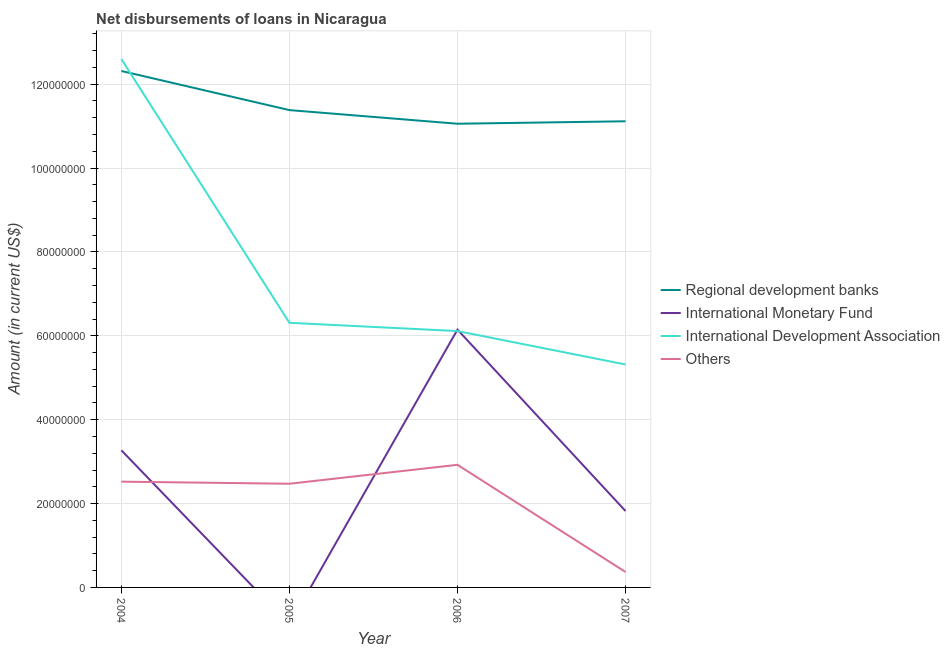Is the number of lines equal to the number of legend labels?
Provide a succinct answer. No. What is the amount of loan disimbursed by international monetary fund in 2006?
Give a very brief answer. 6.15e+07. Across all years, what is the maximum amount of loan disimbursed by regional development banks?
Keep it short and to the point. 1.23e+08. What is the total amount of loan disimbursed by international monetary fund in the graph?
Ensure brevity in your answer.  1.12e+08. What is the difference between the amount of loan disimbursed by other organisations in 2004 and that in 2006?
Offer a very short reply. -4.02e+06. What is the difference between the amount of loan disimbursed by international monetary fund in 2004 and the amount of loan disimbursed by regional development banks in 2006?
Your answer should be compact. -7.79e+07. What is the average amount of loan disimbursed by regional development banks per year?
Keep it short and to the point. 1.15e+08. In the year 2004, what is the difference between the amount of loan disimbursed by international development association and amount of loan disimbursed by international monetary fund?
Provide a short and direct response. 9.33e+07. In how many years, is the amount of loan disimbursed by regional development banks greater than 8000000 US$?
Keep it short and to the point. 4. What is the ratio of the amount of loan disimbursed by regional development banks in 2006 to that in 2007?
Give a very brief answer. 0.99. What is the difference between the highest and the second highest amount of loan disimbursed by other organisations?
Make the answer very short. 4.02e+06. What is the difference between the highest and the lowest amount of loan disimbursed by international monetary fund?
Provide a short and direct response. 6.15e+07. Is the sum of the amount of loan disimbursed by regional development banks in 2004 and 2005 greater than the maximum amount of loan disimbursed by international monetary fund across all years?
Offer a very short reply. Yes. Is it the case that in every year, the sum of the amount of loan disimbursed by regional development banks and amount of loan disimbursed by international monetary fund is greater than the amount of loan disimbursed by international development association?
Ensure brevity in your answer.  Yes. Does the amount of loan disimbursed by international monetary fund monotonically increase over the years?
Your response must be concise. No. Is the amount of loan disimbursed by international monetary fund strictly greater than the amount of loan disimbursed by international development association over the years?
Provide a short and direct response. No. How many lines are there?
Keep it short and to the point. 4. Does the graph contain grids?
Make the answer very short. Yes. Where does the legend appear in the graph?
Provide a short and direct response. Center right. How are the legend labels stacked?
Offer a very short reply. Vertical. What is the title of the graph?
Make the answer very short. Net disbursements of loans in Nicaragua. Does "Fish species" appear as one of the legend labels in the graph?
Keep it short and to the point. No. What is the label or title of the X-axis?
Provide a short and direct response. Year. What is the label or title of the Y-axis?
Your answer should be very brief. Amount (in current US$). What is the Amount (in current US$) of Regional development banks in 2004?
Your answer should be very brief. 1.23e+08. What is the Amount (in current US$) in International Monetary Fund in 2004?
Ensure brevity in your answer.  3.27e+07. What is the Amount (in current US$) of International Development Association in 2004?
Your response must be concise. 1.26e+08. What is the Amount (in current US$) of Others in 2004?
Provide a succinct answer. 2.52e+07. What is the Amount (in current US$) of Regional development banks in 2005?
Give a very brief answer. 1.14e+08. What is the Amount (in current US$) in International Monetary Fund in 2005?
Give a very brief answer. 0. What is the Amount (in current US$) in International Development Association in 2005?
Your response must be concise. 6.31e+07. What is the Amount (in current US$) in Others in 2005?
Your response must be concise. 2.47e+07. What is the Amount (in current US$) in Regional development banks in 2006?
Give a very brief answer. 1.11e+08. What is the Amount (in current US$) in International Monetary Fund in 2006?
Give a very brief answer. 6.15e+07. What is the Amount (in current US$) in International Development Association in 2006?
Keep it short and to the point. 6.11e+07. What is the Amount (in current US$) of Others in 2006?
Offer a terse response. 2.92e+07. What is the Amount (in current US$) of Regional development banks in 2007?
Your answer should be compact. 1.11e+08. What is the Amount (in current US$) of International Monetary Fund in 2007?
Offer a terse response. 1.82e+07. What is the Amount (in current US$) of International Development Association in 2007?
Your answer should be compact. 5.32e+07. What is the Amount (in current US$) of Others in 2007?
Offer a terse response. 3.68e+06. Across all years, what is the maximum Amount (in current US$) in Regional development banks?
Provide a succinct answer. 1.23e+08. Across all years, what is the maximum Amount (in current US$) of International Monetary Fund?
Provide a short and direct response. 6.15e+07. Across all years, what is the maximum Amount (in current US$) of International Development Association?
Your response must be concise. 1.26e+08. Across all years, what is the maximum Amount (in current US$) in Others?
Offer a very short reply. 2.92e+07. Across all years, what is the minimum Amount (in current US$) in Regional development banks?
Give a very brief answer. 1.11e+08. Across all years, what is the minimum Amount (in current US$) of International Monetary Fund?
Give a very brief answer. 0. Across all years, what is the minimum Amount (in current US$) of International Development Association?
Your response must be concise. 5.32e+07. Across all years, what is the minimum Amount (in current US$) of Others?
Give a very brief answer. 3.68e+06. What is the total Amount (in current US$) of Regional development banks in the graph?
Your response must be concise. 4.59e+08. What is the total Amount (in current US$) of International Monetary Fund in the graph?
Keep it short and to the point. 1.12e+08. What is the total Amount (in current US$) of International Development Association in the graph?
Provide a succinct answer. 3.03e+08. What is the total Amount (in current US$) of Others in the graph?
Keep it short and to the point. 8.29e+07. What is the difference between the Amount (in current US$) in Regional development banks in 2004 and that in 2005?
Give a very brief answer. 9.33e+06. What is the difference between the Amount (in current US$) of International Development Association in 2004 and that in 2005?
Make the answer very short. 6.29e+07. What is the difference between the Amount (in current US$) of Others in 2004 and that in 2005?
Offer a terse response. 4.97e+05. What is the difference between the Amount (in current US$) in Regional development banks in 2004 and that in 2006?
Your response must be concise. 1.26e+07. What is the difference between the Amount (in current US$) in International Monetary Fund in 2004 and that in 2006?
Make the answer very short. -2.88e+07. What is the difference between the Amount (in current US$) of International Development Association in 2004 and that in 2006?
Make the answer very short. 6.48e+07. What is the difference between the Amount (in current US$) in Others in 2004 and that in 2006?
Keep it short and to the point. -4.02e+06. What is the difference between the Amount (in current US$) of Regional development banks in 2004 and that in 2007?
Ensure brevity in your answer.  1.20e+07. What is the difference between the Amount (in current US$) in International Monetary Fund in 2004 and that in 2007?
Offer a very short reply. 1.45e+07. What is the difference between the Amount (in current US$) in International Development Association in 2004 and that in 2007?
Offer a terse response. 7.28e+07. What is the difference between the Amount (in current US$) of Others in 2004 and that in 2007?
Your response must be concise. 2.15e+07. What is the difference between the Amount (in current US$) of Regional development banks in 2005 and that in 2006?
Your answer should be very brief. 3.25e+06. What is the difference between the Amount (in current US$) of International Development Association in 2005 and that in 2006?
Make the answer very short. 1.97e+06. What is the difference between the Amount (in current US$) of Others in 2005 and that in 2006?
Offer a very short reply. -4.52e+06. What is the difference between the Amount (in current US$) in Regional development banks in 2005 and that in 2007?
Your answer should be compact. 2.66e+06. What is the difference between the Amount (in current US$) of International Development Association in 2005 and that in 2007?
Offer a terse response. 9.94e+06. What is the difference between the Amount (in current US$) in Others in 2005 and that in 2007?
Offer a terse response. 2.10e+07. What is the difference between the Amount (in current US$) in Regional development banks in 2006 and that in 2007?
Offer a terse response. -5.87e+05. What is the difference between the Amount (in current US$) in International Monetary Fund in 2006 and that in 2007?
Your answer should be very brief. 4.33e+07. What is the difference between the Amount (in current US$) in International Development Association in 2006 and that in 2007?
Your answer should be compact. 7.97e+06. What is the difference between the Amount (in current US$) in Others in 2006 and that in 2007?
Offer a terse response. 2.56e+07. What is the difference between the Amount (in current US$) of Regional development banks in 2004 and the Amount (in current US$) of International Development Association in 2005?
Keep it short and to the point. 6.00e+07. What is the difference between the Amount (in current US$) in Regional development banks in 2004 and the Amount (in current US$) in Others in 2005?
Ensure brevity in your answer.  9.84e+07. What is the difference between the Amount (in current US$) in International Monetary Fund in 2004 and the Amount (in current US$) in International Development Association in 2005?
Offer a terse response. -3.04e+07. What is the difference between the Amount (in current US$) of International Monetary Fund in 2004 and the Amount (in current US$) of Others in 2005?
Offer a terse response. 7.97e+06. What is the difference between the Amount (in current US$) of International Development Association in 2004 and the Amount (in current US$) of Others in 2005?
Ensure brevity in your answer.  1.01e+08. What is the difference between the Amount (in current US$) of Regional development banks in 2004 and the Amount (in current US$) of International Monetary Fund in 2006?
Your response must be concise. 6.17e+07. What is the difference between the Amount (in current US$) in Regional development banks in 2004 and the Amount (in current US$) in International Development Association in 2006?
Give a very brief answer. 6.20e+07. What is the difference between the Amount (in current US$) of Regional development banks in 2004 and the Amount (in current US$) of Others in 2006?
Offer a terse response. 9.39e+07. What is the difference between the Amount (in current US$) of International Monetary Fund in 2004 and the Amount (in current US$) of International Development Association in 2006?
Your answer should be compact. -2.84e+07. What is the difference between the Amount (in current US$) of International Monetary Fund in 2004 and the Amount (in current US$) of Others in 2006?
Offer a very short reply. 3.45e+06. What is the difference between the Amount (in current US$) in International Development Association in 2004 and the Amount (in current US$) in Others in 2006?
Provide a succinct answer. 9.67e+07. What is the difference between the Amount (in current US$) of Regional development banks in 2004 and the Amount (in current US$) of International Monetary Fund in 2007?
Your answer should be compact. 1.05e+08. What is the difference between the Amount (in current US$) in Regional development banks in 2004 and the Amount (in current US$) in International Development Association in 2007?
Make the answer very short. 7.00e+07. What is the difference between the Amount (in current US$) of Regional development banks in 2004 and the Amount (in current US$) of Others in 2007?
Offer a terse response. 1.19e+08. What is the difference between the Amount (in current US$) in International Monetary Fund in 2004 and the Amount (in current US$) in International Development Association in 2007?
Offer a very short reply. -2.05e+07. What is the difference between the Amount (in current US$) in International Monetary Fund in 2004 and the Amount (in current US$) in Others in 2007?
Offer a very short reply. 2.90e+07. What is the difference between the Amount (in current US$) of International Development Association in 2004 and the Amount (in current US$) of Others in 2007?
Your answer should be very brief. 1.22e+08. What is the difference between the Amount (in current US$) of Regional development banks in 2005 and the Amount (in current US$) of International Monetary Fund in 2006?
Offer a very short reply. 5.23e+07. What is the difference between the Amount (in current US$) of Regional development banks in 2005 and the Amount (in current US$) of International Development Association in 2006?
Keep it short and to the point. 5.27e+07. What is the difference between the Amount (in current US$) of Regional development banks in 2005 and the Amount (in current US$) of Others in 2006?
Keep it short and to the point. 8.46e+07. What is the difference between the Amount (in current US$) in International Development Association in 2005 and the Amount (in current US$) in Others in 2006?
Make the answer very short. 3.39e+07. What is the difference between the Amount (in current US$) of Regional development banks in 2005 and the Amount (in current US$) of International Monetary Fund in 2007?
Your answer should be very brief. 9.56e+07. What is the difference between the Amount (in current US$) of Regional development banks in 2005 and the Amount (in current US$) of International Development Association in 2007?
Offer a terse response. 6.07e+07. What is the difference between the Amount (in current US$) of Regional development banks in 2005 and the Amount (in current US$) of Others in 2007?
Provide a short and direct response. 1.10e+08. What is the difference between the Amount (in current US$) of International Development Association in 2005 and the Amount (in current US$) of Others in 2007?
Make the answer very short. 5.94e+07. What is the difference between the Amount (in current US$) of Regional development banks in 2006 and the Amount (in current US$) of International Monetary Fund in 2007?
Your response must be concise. 9.23e+07. What is the difference between the Amount (in current US$) in Regional development banks in 2006 and the Amount (in current US$) in International Development Association in 2007?
Your answer should be very brief. 5.74e+07. What is the difference between the Amount (in current US$) of Regional development banks in 2006 and the Amount (in current US$) of Others in 2007?
Provide a short and direct response. 1.07e+08. What is the difference between the Amount (in current US$) in International Monetary Fund in 2006 and the Amount (in current US$) in International Development Association in 2007?
Ensure brevity in your answer.  8.32e+06. What is the difference between the Amount (in current US$) of International Monetary Fund in 2006 and the Amount (in current US$) of Others in 2007?
Your answer should be very brief. 5.78e+07. What is the difference between the Amount (in current US$) in International Development Association in 2006 and the Amount (in current US$) in Others in 2007?
Your answer should be compact. 5.74e+07. What is the average Amount (in current US$) in Regional development banks per year?
Provide a succinct answer. 1.15e+08. What is the average Amount (in current US$) in International Monetary Fund per year?
Offer a terse response. 2.81e+07. What is the average Amount (in current US$) of International Development Association per year?
Provide a succinct answer. 7.58e+07. What is the average Amount (in current US$) in Others per year?
Offer a terse response. 2.07e+07. In the year 2004, what is the difference between the Amount (in current US$) in Regional development banks and Amount (in current US$) in International Monetary Fund?
Provide a succinct answer. 9.05e+07. In the year 2004, what is the difference between the Amount (in current US$) in Regional development banks and Amount (in current US$) in International Development Association?
Your answer should be compact. -2.84e+06. In the year 2004, what is the difference between the Amount (in current US$) in Regional development banks and Amount (in current US$) in Others?
Keep it short and to the point. 9.79e+07. In the year 2004, what is the difference between the Amount (in current US$) in International Monetary Fund and Amount (in current US$) in International Development Association?
Ensure brevity in your answer.  -9.33e+07. In the year 2004, what is the difference between the Amount (in current US$) in International Monetary Fund and Amount (in current US$) in Others?
Provide a short and direct response. 7.47e+06. In the year 2004, what is the difference between the Amount (in current US$) in International Development Association and Amount (in current US$) in Others?
Your answer should be compact. 1.01e+08. In the year 2005, what is the difference between the Amount (in current US$) in Regional development banks and Amount (in current US$) in International Development Association?
Your answer should be very brief. 5.07e+07. In the year 2005, what is the difference between the Amount (in current US$) of Regional development banks and Amount (in current US$) of Others?
Your response must be concise. 8.91e+07. In the year 2005, what is the difference between the Amount (in current US$) of International Development Association and Amount (in current US$) of Others?
Make the answer very short. 3.84e+07. In the year 2006, what is the difference between the Amount (in current US$) of Regional development banks and Amount (in current US$) of International Monetary Fund?
Offer a very short reply. 4.91e+07. In the year 2006, what is the difference between the Amount (in current US$) of Regional development banks and Amount (in current US$) of International Development Association?
Ensure brevity in your answer.  4.94e+07. In the year 2006, what is the difference between the Amount (in current US$) in Regional development banks and Amount (in current US$) in Others?
Offer a terse response. 8.13e+07. In the year 2006, what is the difference between the Amount (in current US$) in International Monetary Fund and Amount (in current US$) in International Development Association?
Provide a succinct answer. 3.43e+05. In the year 2006, what is the difference between the Amount (in current US$) in International Monetary Fund and Amount (in current US$) in Others?
Offer a terse response. 3.22e+07. In the year 2006, what is the difference between the Amount (in current US$) of International Development Association and Amount (in current US$) of Others?
Provide a succinct answer. 3.19e+07. In the year 2007, what is the difference between the Amount (in current US$) in Regional development banks and Amount (in current US$) in International Monetary Fund?
Give a very brief answer. 9.29e+07. In the year 2007, what is the difference between the Amount (in current US$) of Regional development banks and Amount (in current US$) of International Development Association?
Provide a short and direct response. 5.80e+07. In the year 2007, what is the difference between the Amount (in current US$) in Regional development banks and Amount (in current US$) in Others?
Make the answer very short. 1.07e+08. In the year 2007, what is the difference between the Amount (in current US$) of International Monetary Fund and Amount (in current US$) of International Development Association?
Your answer should be very brief. -3.49e+07. In the year 2007, what is the difference between the Amount (in current US$) of International Monetary Fund and Amount (in current US$) of Others?
Give a very brief answer. 1.45e+07. In the year 2007, what is the difference between the Amount (in current US$) in International Development Association and Amount (in current US$) in Others?
Offer a terse response. 4.95e+07. What is the ratio of the Amount (in current US$) in Regional development banks in 2004 to that in 2005?
Your answer should be compact. 1.08. What is the ratio of the Amount (in current US$) of International Development Association in 2004 to that in 2005?
Provide a succinct answer. 2. What is the ratio of the Amount (in current US$) in Others in 2004 to that in 2005?
Your answer should be very brief. 1.02. What is the ratio of the Amount (in current US$) in Regional development banks in 2004 to that in 2006?
Provide a short and direct response. 1.11. What is the ratio of the Amount (in current US$) of International Monetary Fund in 2004 to that in 2006?
Ensure brevity in your answer.  0.53. What is the ratio of the Amount (in current US$) of International Development Association in 2004 to that in 2006?
Your answer should be compact. 2.06. What is the ratio of the Amount (in current US$) of Others in 2004 to that in 2006?
Your answer should be very brief. 0.86. What is the ratio of the Amount (in current US$) of Regional development banks in 2004 to that in 2007?
Offer a very short reply. 1.11. What is the ratio of the Amount (in current US$) of International Monetary Fund in 2004 to that in 2007?
Provide a succinct answer. 1.79. What is the ratio of the Amount (in current US$) in International Development Association in 2004 to that in 2007?
Provide a succinct answer. 2.37. What is the ratio of the Amount (in current US$) of Others in 2004 to that in 2007?
Ensure brevity in your answer.  6.85. What is the ratio of the Amount (in current US$) in Regional development banks in 2005 to that in 2006?
Offer a very short reply. 1.03. What is the ratio of the Amount (in current US$) in International Development Association in 2005 to that in 2006?
Keep it short and to the point. 1.03. What is the ratio of the Amount (in current US$) in Others in 2005 to that in 2006?
Keep it short and to the point. 0.85. What is the ratio of the Amount (in current US$) in International Development Association in 2005 to that in 2007?
Make the answer very short. 1.19. What is the ratio of the Amount (in current US$) of Others in 2005 to that in 2007?
Keep it short and to the point. 6.71. What is the ratio of the Amount (in current US$) of Regional development banks in 2006 to that in 2007?
Your response must be concise. 0.99. What is the ratio of the Amount (in current US$) in International Monetary Fund in 2006 to that in 2007?
Make the answer very short. 3.37. What is the ratio of the Amount (in current US$) in International Development Association in 2006 to that in 2007?
Provide a succinct answer. 1.15. What is the ratio of the Amount (in current US$) of Others in 2006 to that in 2007?
Your response must be concise. 7.94. What is the difference between the highest and the second highest Amount (in current US$) of Regional development banks?
Offer a very short reply. 9.33e+06. What is the difference between the highest and the second highest Amount (in current US$) of International Monetary Fund?
Provide a short and direct response. 2.88e+07. What is the difference between the highest and the second highest Amount (in current US$) of International Development Association?
Give a very brief answer. 6.29e+07. What is the difference between the highest and the second highest Amount (in current US$) of Others?
Give a very brief answer. 4.02e+06. What is the difference between the highest and the lowest Amount (in current US$) of Regional development banks?
Provide a succinct answer. 1.26e+07. What is the difference between the highest and the lowest Amount (in current US$) of International Monetary Fund?
Make the answer very short. 6.15e+07. What is the difference between the highest and the lowest Amount (in current US$) of International Development Association?
Provide a short and direct response. 7.28e+07. What is the difference between the highest and the lowest Amount (in current US$) in Others?
Provide a short and direct response. 2.56e+07. 